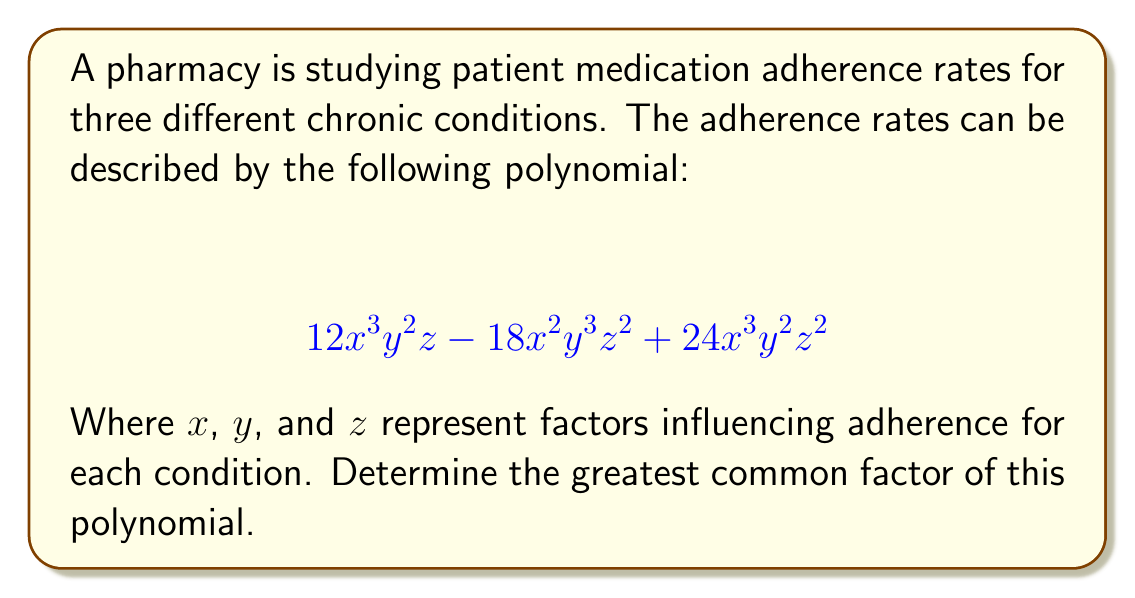Give your solution to this math problem. To find the greatest common factor (GCF) of the polynomial, we need to follow these steps:

1) Identify the GCF of the coefficients:
   $GCF(12, 18, 24) = 6$

2) Determine the common variables with their lowest exponents:
   $x$ appears in all terms, with the lowest exponent of 2
   $y$ appears in all terms, with the lowest exponent of 2
   $z$ appears in all terms, with the lowest exponent of 1

3) Combine the GCF of the coefficients with the common variables:
   $6x^2y^2z$

4) Verify by factoring out the GCF:
   $$ 6x^2y^2z(2xy - 3yz + 4xz) $$

This factorization confirms that $6x^2y^2z$ is indeed the greatest common factor.
Answer: $6x^2y^2z$ 